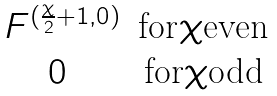<formula> <loc_0><loc_0><loc_500><loc_500>\begin{matrix} \ F ^ { ( \frac { \chi } { 2 } + 1 , 0 ) } & \text {for} \chi \text {even} \\ 0 & \text {for} \chi \text {odd} \end{matrix}</formula> 